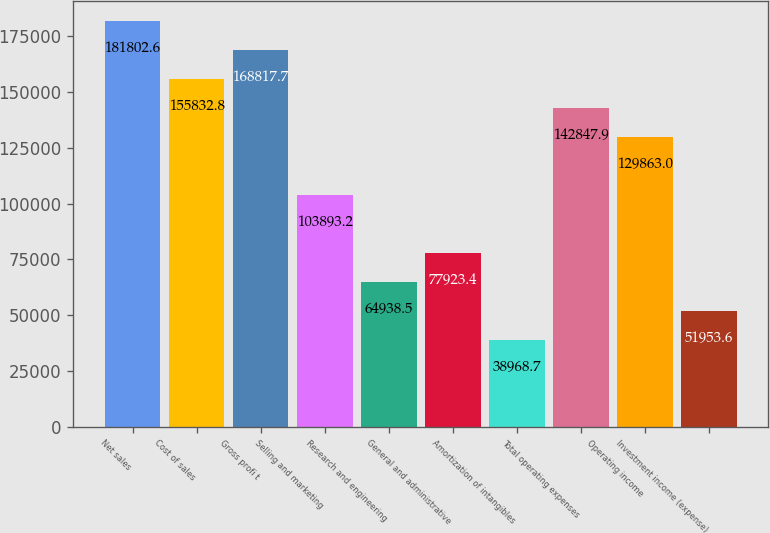Convert chart to OTSL. <chart><loc_0><loc_0><loc_500><loc_500><bar_chart><fcel>Net sales<fcel>Cost of sales<fcel>Gross profi t<fcel>Selling and marketing<fcel>Research and engineering<fcel>General and administrative<fcel>Amortization of intangibles<fcel>Total operating expenses<fcel>Operating income<fcel>Investment income (expense)<nl><fcel>181803<fcel>155833<fcel>168818<fcel>103893<fcel>64938.5<fcel>77923.4<fcel>38968.7<fcel>142848<fcel>129863<fcel>51953.6<nl></chart> 